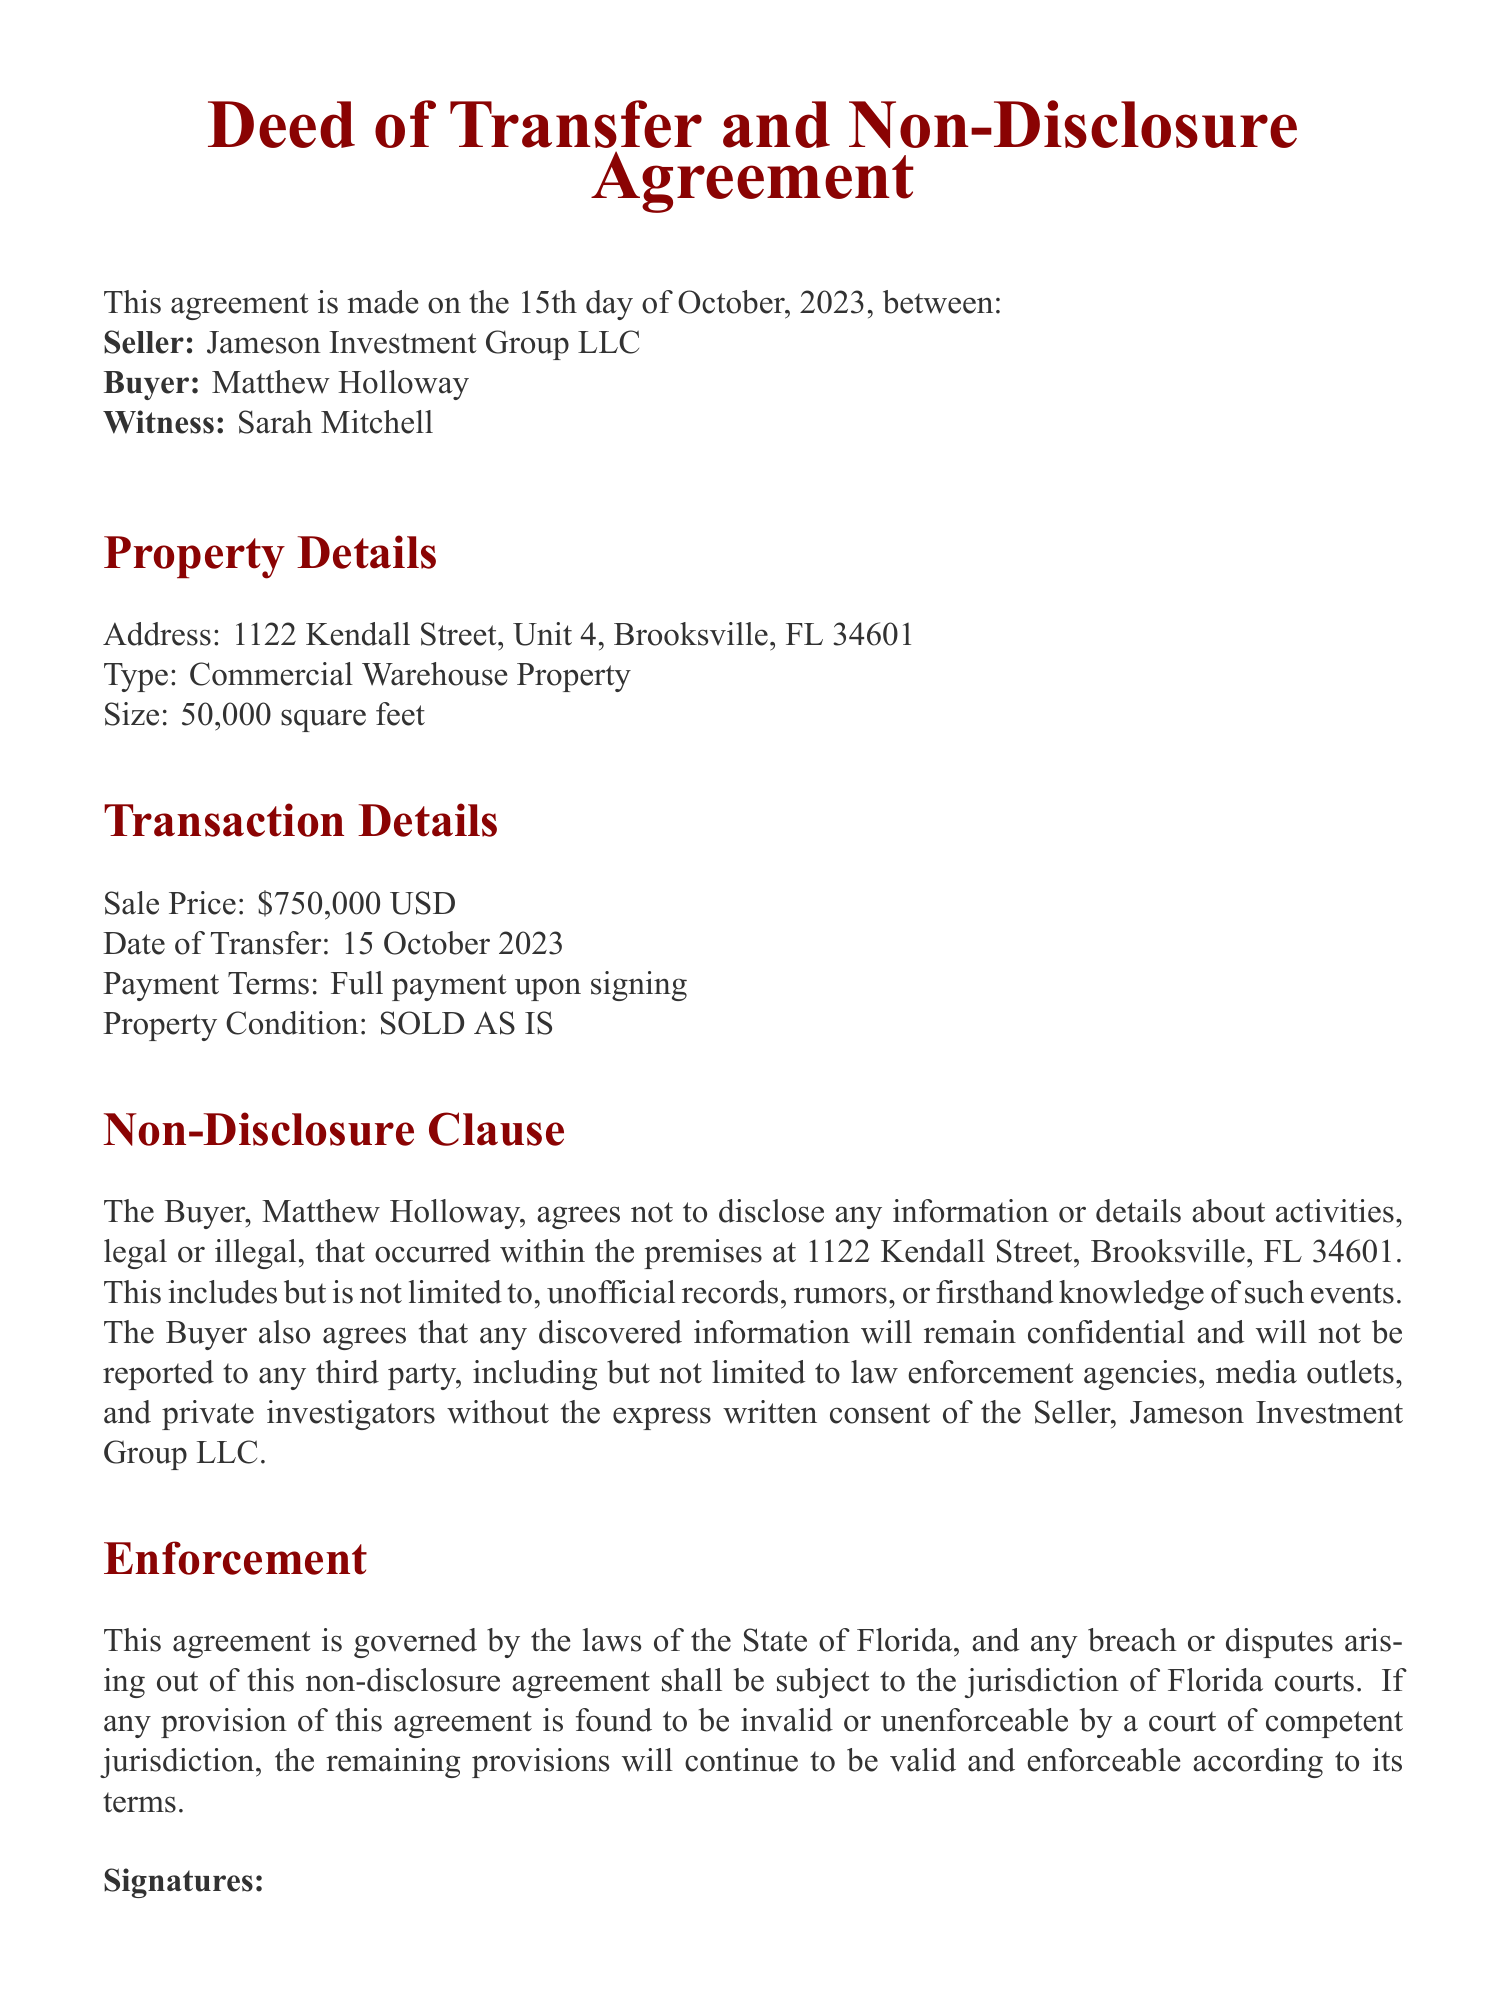What is the name of the Seller? The Seller is identified as Jameson Investment Group LLC in the document.
Answer: Jameson Investment Group LLC What is the Buyer’s full name? The document clearly states that the Buyer is named Matthew Holloway.
Answer: Matthew Holloway What is the sale price of the property? The sale price mentioned in the document is specified under Transaction Details as $750,000 USD.
Answer: $750,000 USD What is the address of the property? The address is listed in the Property Details section as 1122 Kendall Street, Unit 4, Brooksville, FL 34601.
Answer: 1122 Kendall Street, Unit 4, Brooksville, FL 34601 What is the size of the warehouse? The size of the property is noted as 50,000 square feet in the document.
Answer: 50,000 square feet What is the date of transfer? The date of transfer is mentioned in the Transaction Details as 15 October 2023.
Answer: 15 October 2023 What clause prevents disclosure of activities? The Non-Disclosure Clause explicitly states the non-disclosure of information about activities within the premises.
Answer: Non-Disclosure Clause What legal jurisdiction governs the agreement? The document states that the agreement is governed by the laws of the State of Florida.
Answer: State of Florida Who is the witness for the transaction? The witness to the signing of the deed is identified as Sarah Mitchell in the document.
Answer: Sarah Mitchell 